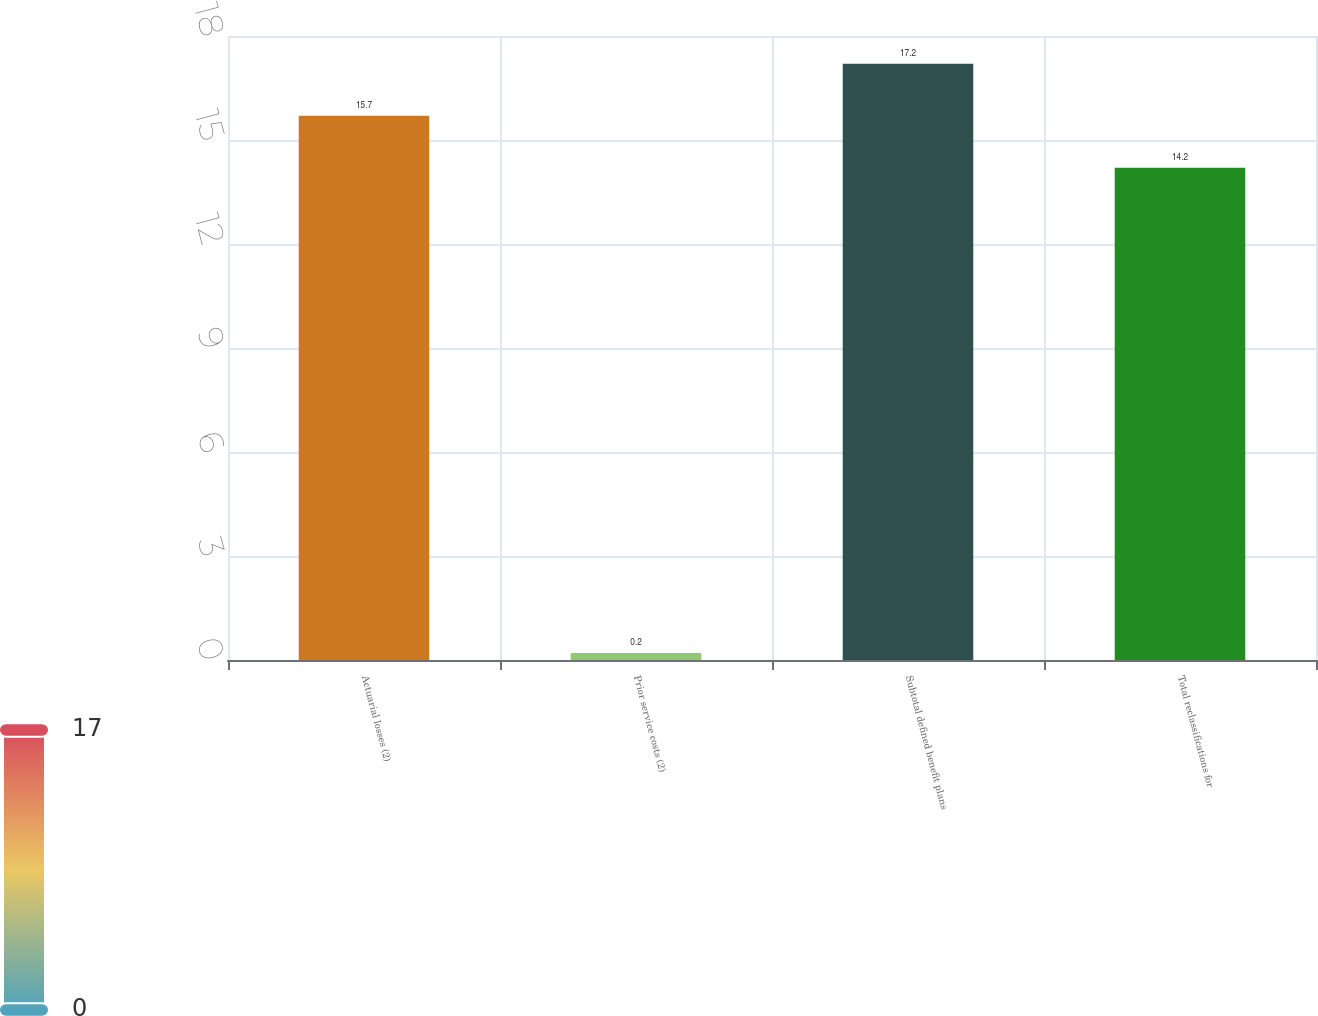Convert chart to OTSL. <chart><loc_0><loc_0><loc_500><loc_500><bar_chart><fcel>Actuarial losses (2)<fcel>Prior service costs (2)<fcel>Subtotal defined benefit plans<fcel>Total reclassifications for<nl><fcel>15.7<fcel>0.2<fcel>17.2<fcel>14.2<nl></chart> 